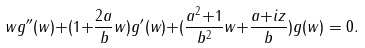<formula> <loc_0><loc_0><loc_500><loc_500>w g ^ { \prime \prime } ( w ) { + } ( 1 { + } \frac { 2 a } { b } w ) g ^ { \prime } ( w ) { + } ( \frac { a ^ { 2 } { + } 1 } { b ^ { 2 } } w { + } \frac { a { + } i z } { b } ) g ( w ) = 0 .</formula> 